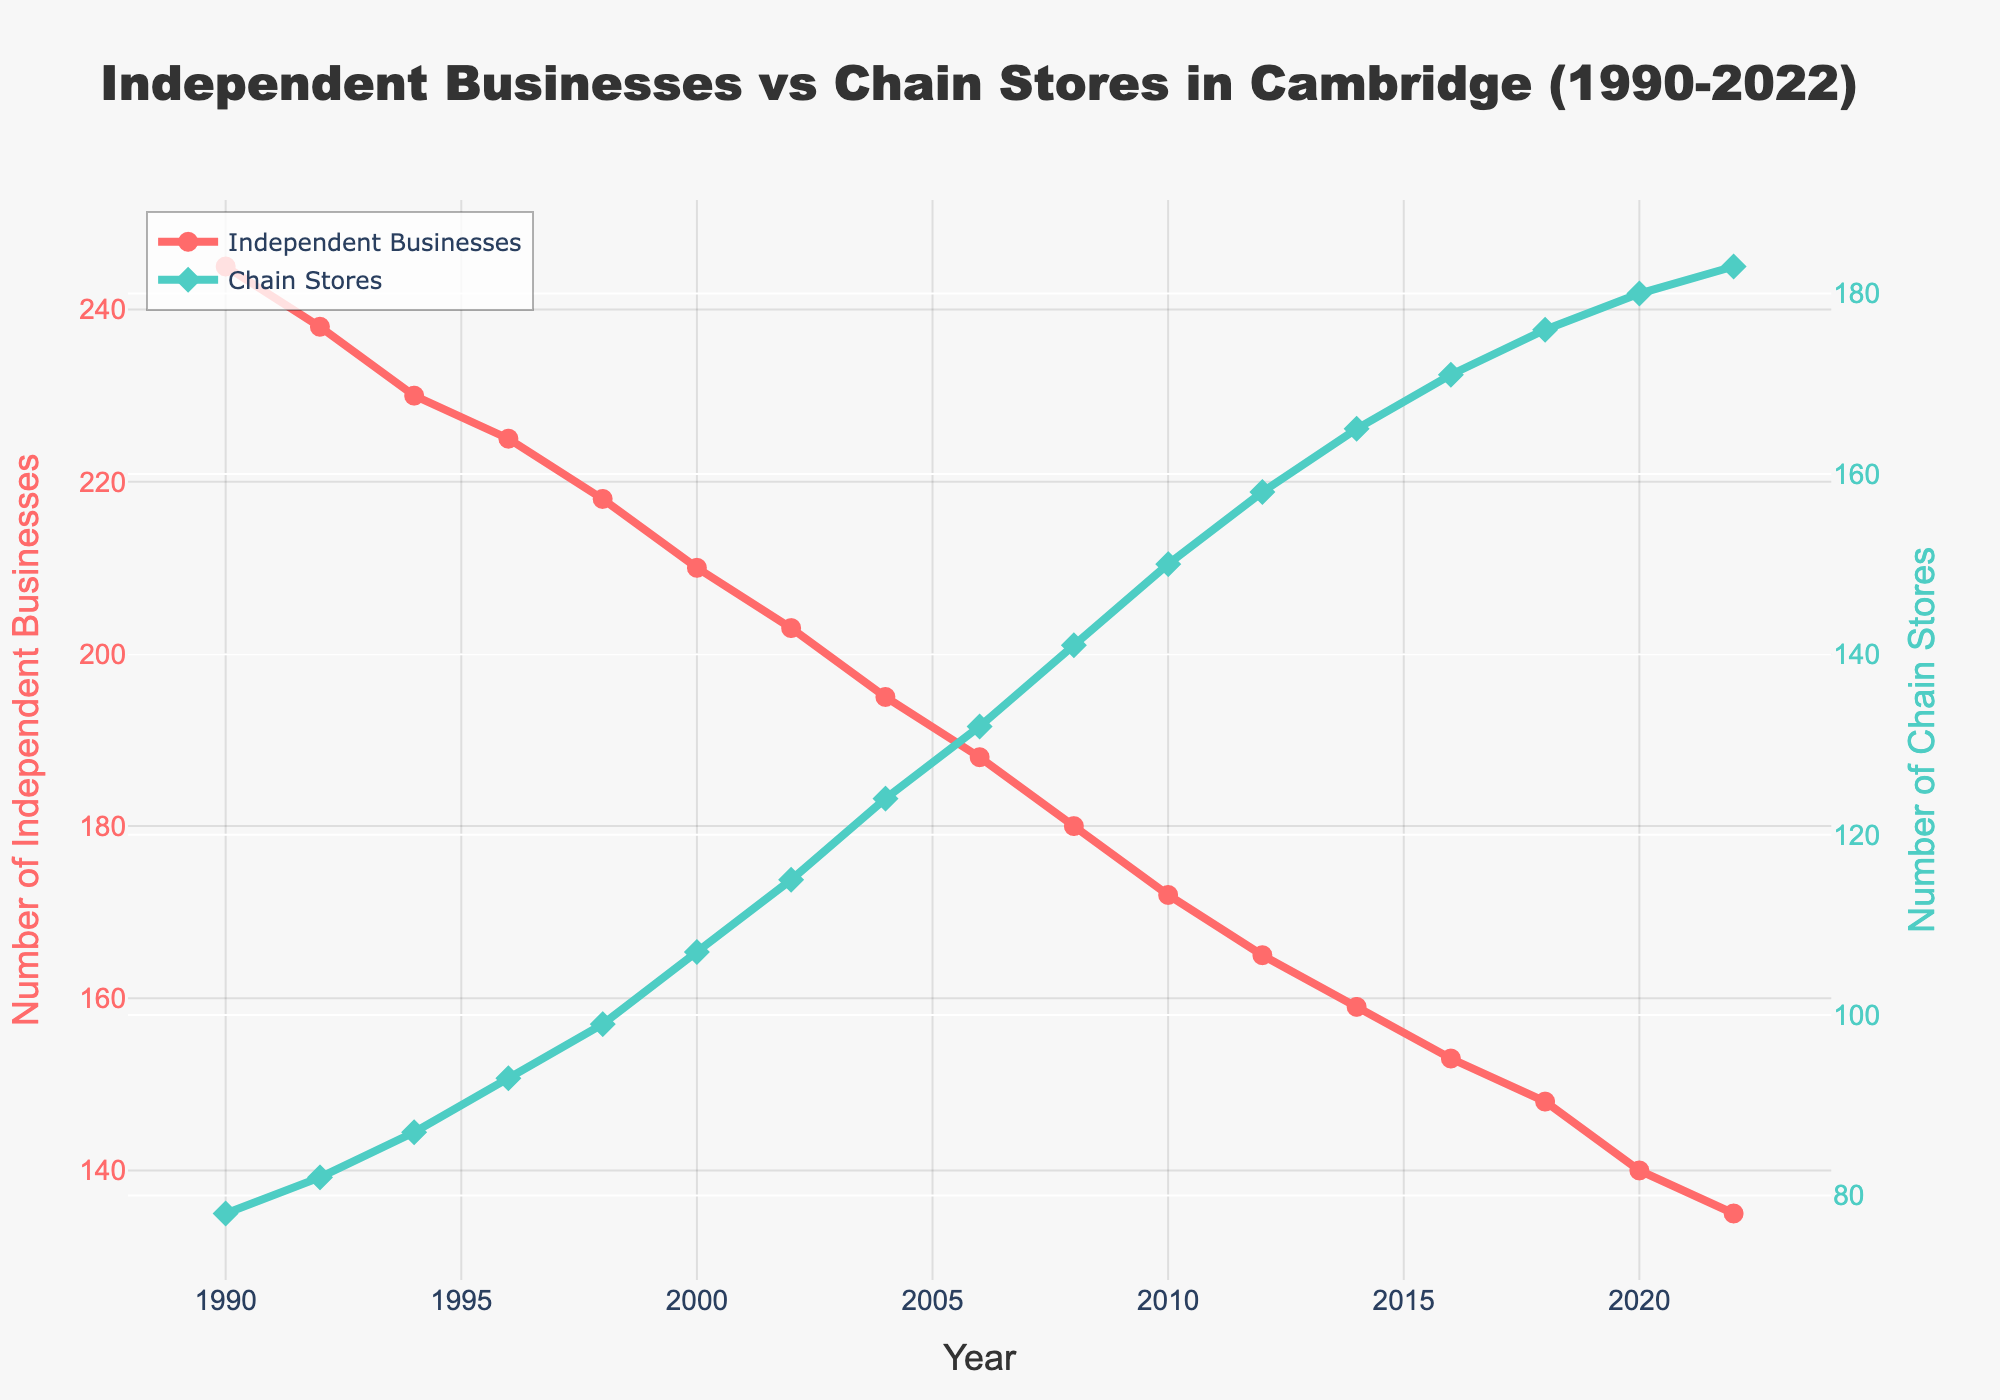What trend is noticeable in the number of independent businesses from 1990 to 2022? The line representing Independent Businesses (in red) shows a clear downward trend from 1990 to 2022, indicating a significant decrease in their numbers over the years.
Answer: Decreasing What is the general trend in the number of chain stores from 1990 to 2022? The line representing Chain Stores (in green) shows a consistent upward trend from 1990 to 2022, indicating a significant increase in their numbers over the years.
Answer: Increasing In which year did the number of chain stores surpass 150? Observing the green line (Chain Stores), it surpasses 150 in the year between 2010 and 2012.
Answer: 2012 How does the number of independent businesses in 1990 compare to the number in 2022? In 1990, the number of independent businesses was 245, whereas, in 2022, it decreased to 135, a difference of 110 fewer independent businesses.
Answer: 110 fewer in 2022 What is the difference in the number of chain stores between the years 2000 and 2020? In 2000, there were 107 chain stores, and in 2020, there were 180 chain stores. The difference is 180 - 107 = 73 more chain stores in 2020.
Answer: 73 more in 2020 Which type of business had the higher count in 1994? In 1994, Independent Businesses had a count of 230, whereas Chain Stores had a count of 87. 230 is greater than 87.
Answer: Independent Businesses By how much did the number of independent businesses decrease between 1998 and 2002? In 1998, there were 218 independent businesses, and by 2002, the number was 203. The decrease is 218 - 203 = 15 businesses.
Answer: 15 businesses fewer In which range of years did the number of chain stores increase the fastest? By examining the steepest inclination of the green line, the number of chain stores experienced a notable increase between 2000 and 2004.
Answer: 2000-2004 What portion of the graph shows the blue line consistently above the red line? From 1990 to 2008, the red line (Independent Businesses) is above the green line (Chain Stores), but starting around 2012, the green line surpasses and remains above the red line.
Answer: From around 2012 onwards 